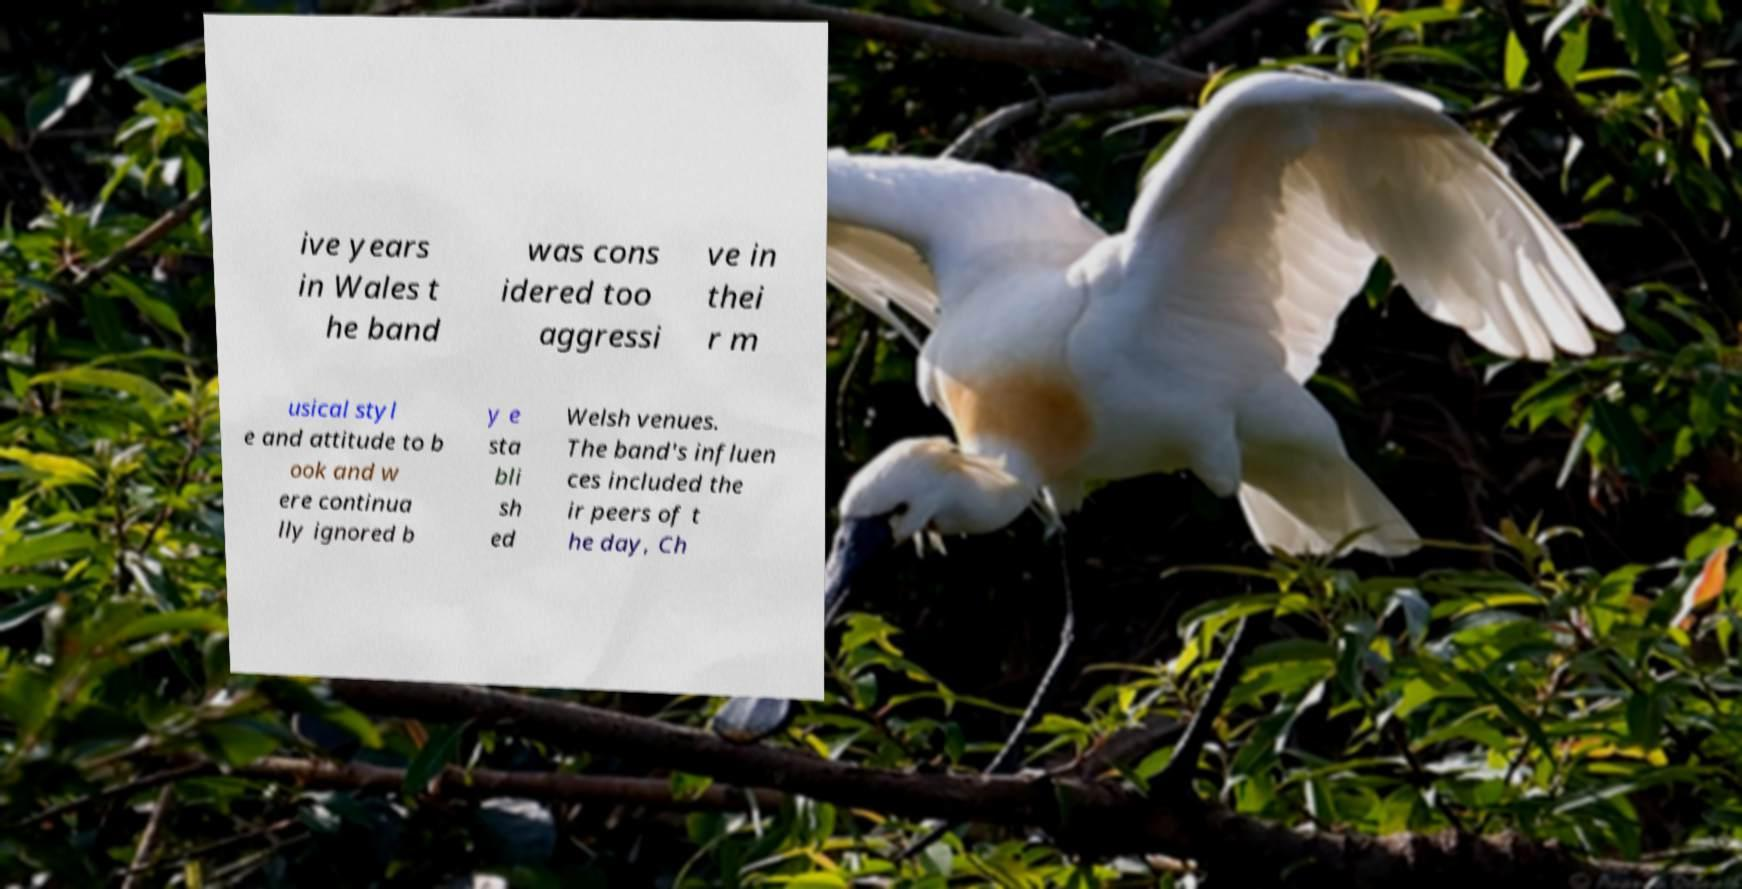Can you accurately transcribe the text from the provided image for me? ive years in Wales t he band was cons idered too aggressi ve in thei r m usical styl e and attitude to b ook and w ere continua lly ignored b y e sta bli sh ed Welsh venues. The band's influen ces included the ir peers of t he day, Ch 